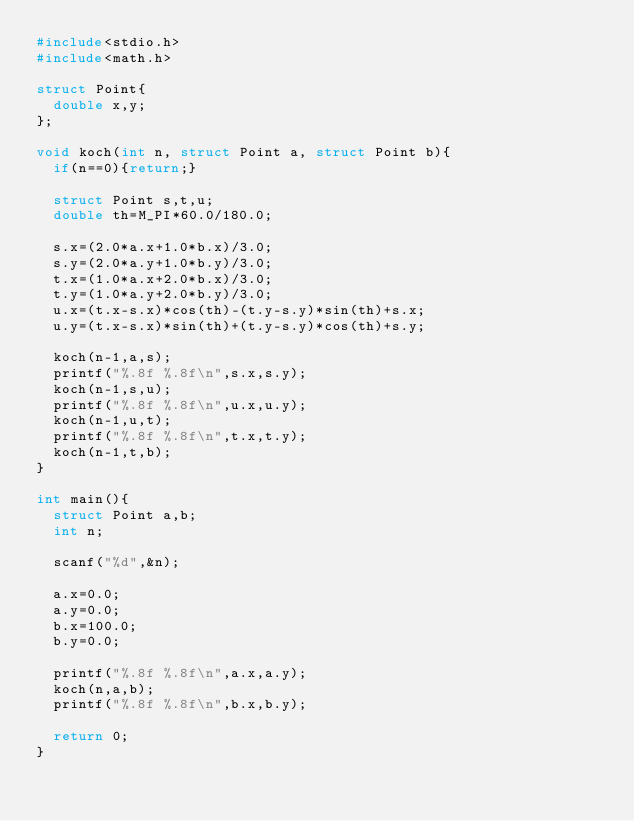Convert code to text. <code><loc_0><loc_0><loc_500><loc_500><_C_>#include<stdio.h>
#include<math.h>

struct Point{
	double x,y;
};

void koch(int n, struct Point a, struct Point b){
	if(n==0){return;}
	
	struct Point s,t,u;
	double th=M_PI*60.0/180.0;
	
	s.x=(2.0*a.x+1.0*b.x)/3.0;
	s.y=(2.0*a.y+1.0*b.y)/3.0;
	t.x=(1.0*a.x+2.0*b.x)/3.0;
	t.y=(1.0*a.y+2.0*b.y)/3.0;
	u.x=(t.x-s.x)*cos(th)-(t.y-s.y)*sin(th)+s.x;
	u.y=(t.x-s.x)*sin(th)+(t.y-s.y)*cos(th)+s.y;
	
	koch(n-1,a,s);
	printf("%.8f %.8f\n",s.x,s.y);
	koch(n-1,s,u);
	printf("%.8f %.8f\n",u.x,u.y);
	koch(n-1,u,t);
	printf("%.8f %.8f\n",t.x,t.y);
	koch(n-1,t,b);
}

int main(){
	struct Point a,b;
	int n;
	
	scanf("%d",&n);
	
	a.x=0.0;
	a.y=0.0;
	b.x=100.0;
	b.y=0.0;
	
	printf("%.8f %.8f\n",a.x,a.y);
	koch(n,a,b);
	printf("%.8f %.8f\n",b.x,b.y);
	
	return 0;
}
</code> 